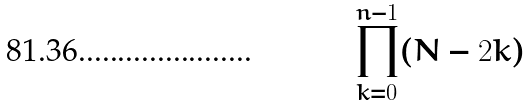Convert formula to latex. <formula><loc_0><loc_0><loc_500><loc_500>\prod _ { k = 0 } ^ { n - 1 } ( N - 2 k )</formula> 